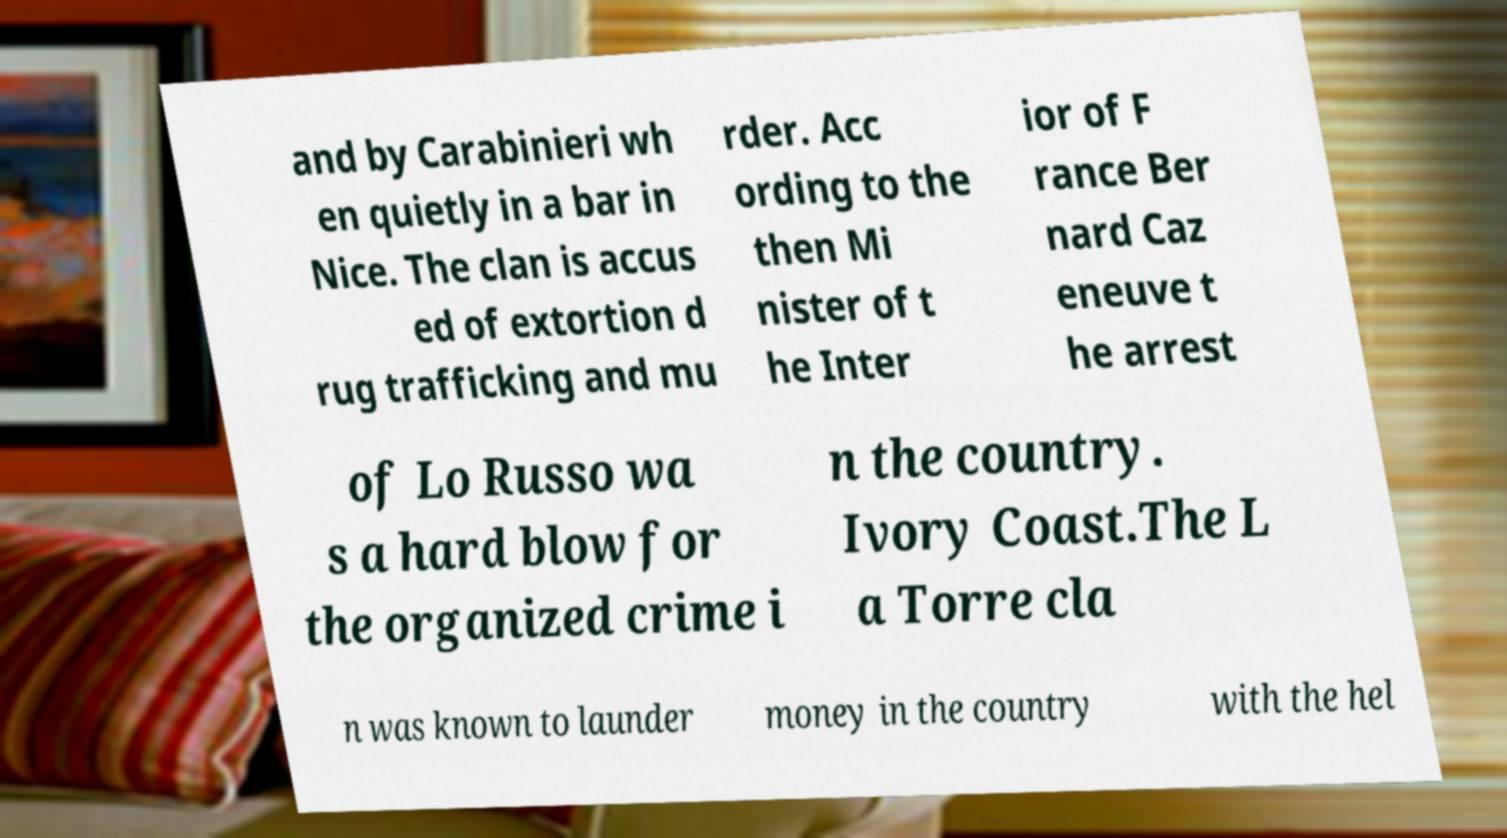Could you assist in decoding the text presented in this image and type it out clearly? and by Carabinieri wh en quietly in a bar in Nice. The clan is accus ed of extortion d rug trafficking and mu rder. Acc ording to the then Mi nister of t he Inter ior of F rance Ber nard Caz eneuve t he arrest of Lo Russo wa s a hard blow for the organized crime i n the country. Ivory Coast.The L a Torre cla n was known to launder money in the country with the hel 